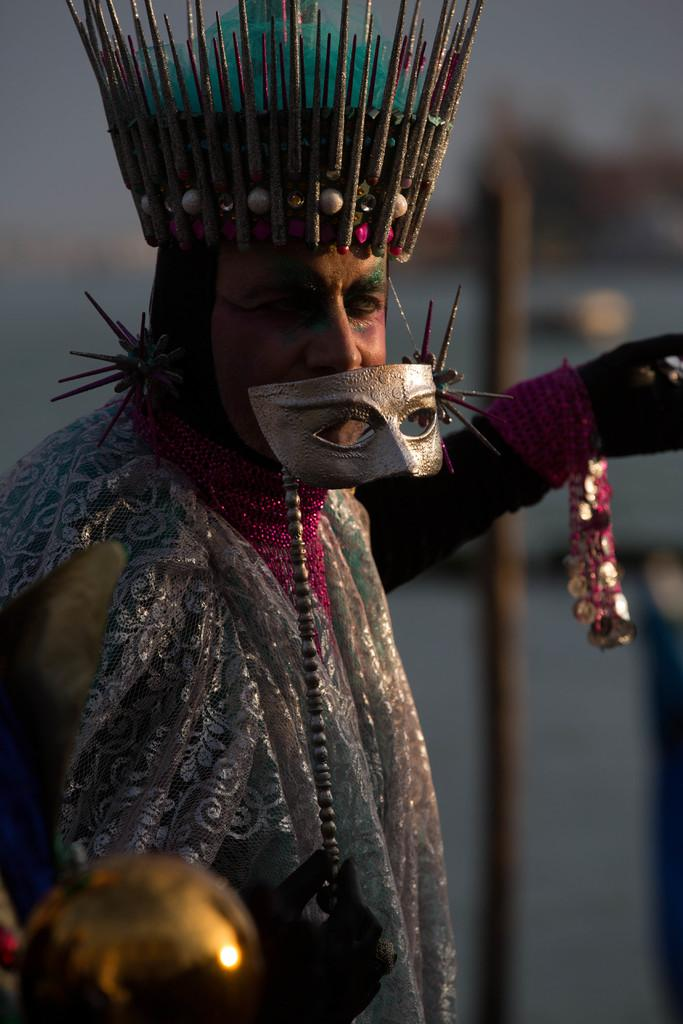What is the main subject of the image? There is a person in the image. What is the person wearing? The person is wearing a costume. What else is the person holding in the image? The person is holding a mask in their hand. What type of accessory is the person wearing on their head? The person is wearing a headband. What can be seen in the background of the image? There is a pole in the background of the image. What does the caption say about the person's sneeze in the image? There is no caption present in the image, and the person's sneeze is not mentioned or depicted. 